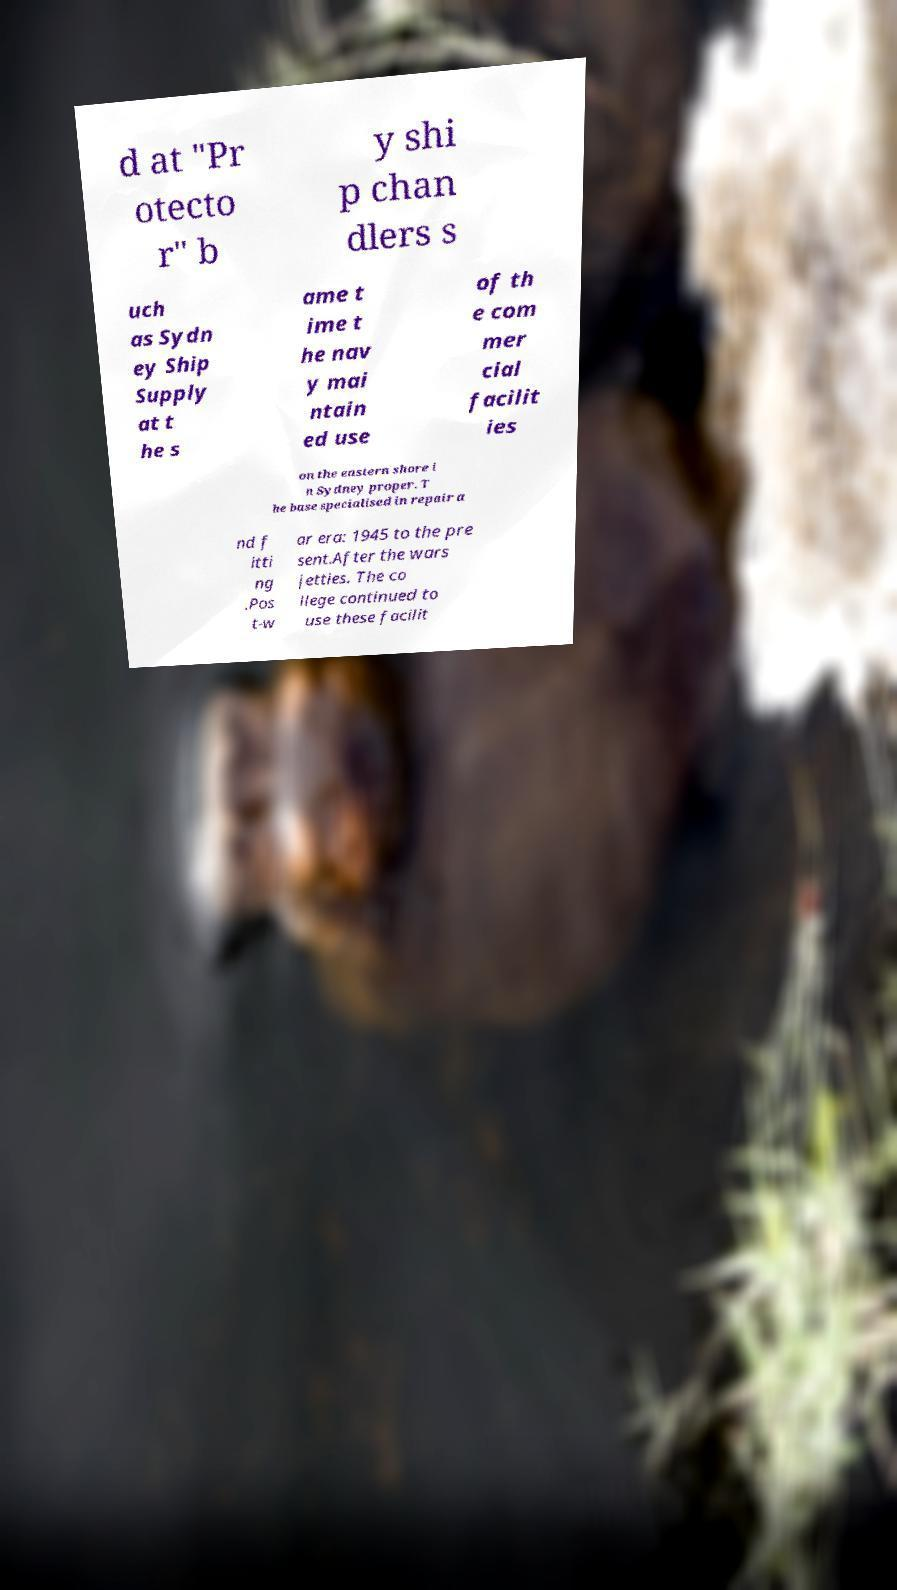Could you extract and type out the text from this image? d at "Pr otecto r" b y shi p chan dlers s uch as Sydn ey Ship Supply at t he s ame t ime t he nav y mai ntain ed use of th e com mer cial facilit ies on the eastern shore i n Sydney proper. T he base specialised in repair a nd f itti ng .Pos t-w ar era: 1945 to the pre sent.After the wars jetties. The co llege continued to use these facilit 